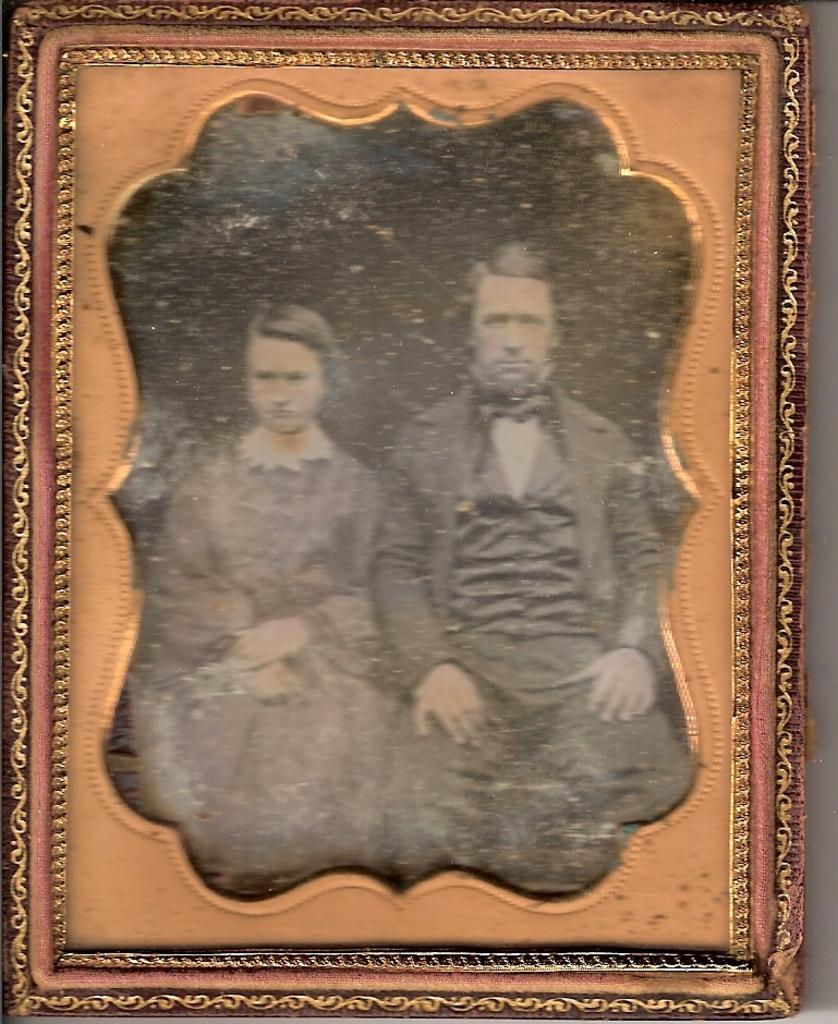What object is present in the image that typically holds a photograph? There is a photo frame in the image. Who is depicted in the photo frame? The photo frame contains a woman. What type of ring is the woman wearing on her head in the image? There is no ring visible on the woman's head in the image. 